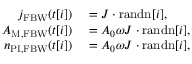<formula> <loc_0><loc_0><loc_500><loc_500>\begin{array} { r l } { j _ { F B W } ( t [ i ] ) } & = J \cdot r a n d n [ i ] , } \\ { A _ { M , F B W } ( t [ i ] ) } & = A _ { 0 } \omega J \cdot r a n d n [ i ] , } \\ { n _ { P I , F B W } ( t [ i ] ) } & = A _ { 0 } \omega J \cdot r a n d n [ i ] , } \end{array}</formula> 